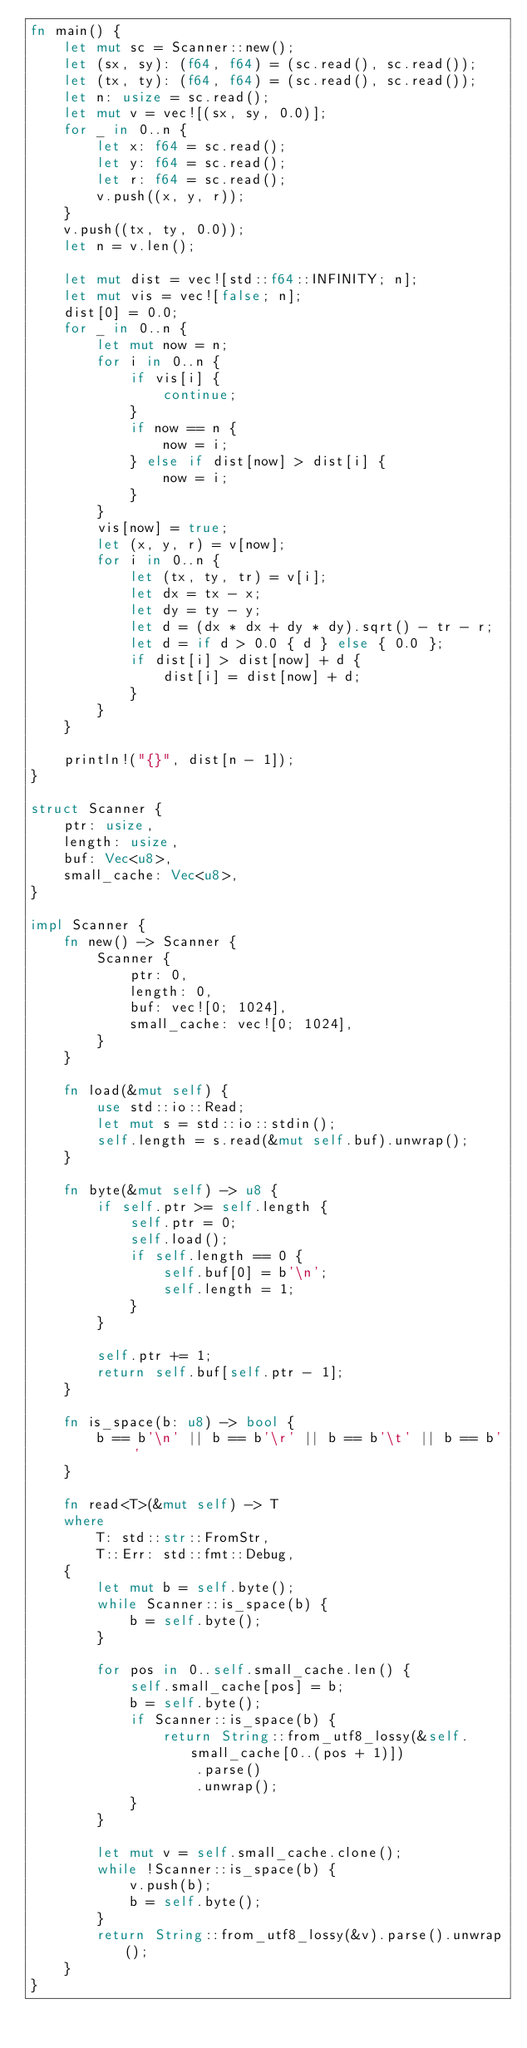Convert code to text. <code><loc_0><loc_0><loc_500><loc_500><_Rust_>fn main() {
    let mut sc = Scanner::new();
    let (sx, sy): (f64, f64) = (sc.read(), sc.read());
    let (tx, ty): (f64, f64) = (sc.read(), sc.read());
    let n: usize = sc.read();
    let mut v = vec![(sx, sy, 0.0)];
    for _ in 0..n {
        let x: f64 = sc.read();
        let y: f64 = sc.read();
        let r: f64 = sc.read();
        v.push((x, y, r));
    }
    v.push((tx, ty, 0.0));
    let n = v.len();

    let mut dist = vec![std::f64::INFINITY; n];
    let mut vis = vec![false; n];
    dist[0] = 0.0;
    for _ in 0..n {
        let mut now = n;
        for i in 0..n {
            if vis[i] {
                continue;
            }
            if now == n {
                now = i;
            } else if dist[now] > dist[i] {
                now = i;
            }
        }
        vis[now] = true;
        let (x, y, r) = v[now];
        for i in 0..n {
            let (tx, ty, tr) = v[i];
            let dx = tx - x;
            let dy = ty - y;
            let d = (dx * dx + dy * dy).sqrt() - tr - r;
            let d = if d > 0.0 { d } else { 0.0 };
            if dist[i] > dist[now] + d {
                dist[i] = dist[now] + d;
            }
        }
    }

    println!("{}", dist[n - 1]);
}

struct Scanner {
    ptr: usize,
    length: usize,
    buf: Vec<u8>,
    small_cache: Vec<u8>,
}

impl Scanner {
    fn new() -> Scanner {
        Scanner {
            ptr: 0,
            length: 0,
            buf: vec![0; 1024],
            small_cache: vec![0; 1024],
        }
    }

    fn load(&mut self) {
        use std::io::Read;
        let mut s = std::io::stdin();
        self.length = s.read(&mut self.buf).unwrap();
    }

    fn byte(&mut self) -> u8 {
        if self.ptr >= self.length {
            self.ptr = 0;
            self.load();
            if self.length == 0 {
                self.buf[0] = b'\n';
                self.length = 1;
            }
        }

        self.ptr += 1;
        return self.buf[self.ptr - 1];
    }

    fn is_space(b: u8) -> bool {
        b == b'\n' || b == b'\r' || b == b'\t' || b == b' '
    }

    fn read<T>(&mut self) -> T
    where
        T: std::str::FromStr,
        T::Err: std::fmt::Debug,
    {
        let mut b = self.byte();
        while Scanner::is_space(b) {
            b = self.byte();
        }

        for pos in 0..self.small_cache.len() {
            self.small_cache[pos] = b;
            b = self.byte();
            if Scanner::is_space(b) {
                return String::from_utf8_lossy(&self.small_cache[0..(pos + 1)])
                    .parse()
                    .unwrap();
            }
        }

        let mut v = self.small_cache.clone();
        while !Scanner::is_space(b) {
            v.push(b);
            b = self.byte();
        }
        return String::from_utf8_lossy(&v).parse().unwrap();
    }
}
</code> 